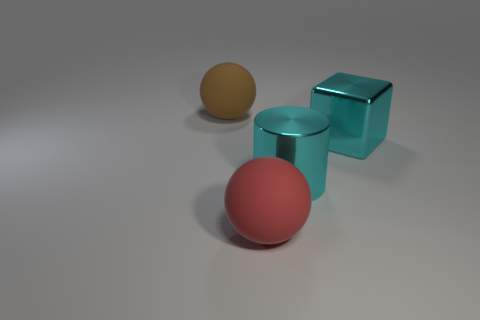Add 3 cyan blocks. How many objects exist? 7 Subtract all cubes. How many objects are left? 3 Add 2 yellow rubber blocks. How many yellow rubber blocks exist? 2 Subtract 1 cyan cubes. How many objects are left? 3 Subtract all tiny cyan cylinders. Subtract all big red objects. How many objects are left? 3 Add 3 brown matte things. How many brown matte things are left? 4 